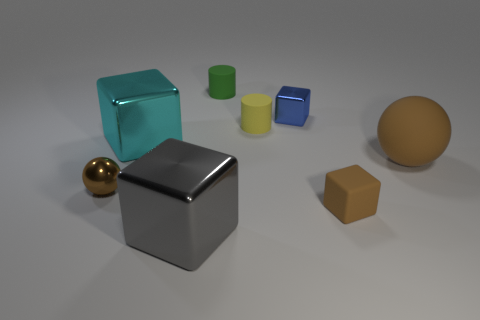What number of other objects are the same color as the small rubber block?
Offer a very short reply. 2. What number of yellow things are either small balls or large balls?
Your response must be concise. 0. Is the shape of the big object right of the small green cylinder the same as the tiny matte thing that is right of the yellow matte cylinder?
Make the answer very short. No. What number of other things are made of the same material as the cyan thing?
Keep it short and to the point. 3. There is a shiny thing in front of the brown thing left of the cyan metal block; is there a small brown block that is in front of it?
Offer a very short reply. No. Is the material of the small brown ball the same as the tiny blue cube?
Your answer should be very brief. Yes. Is there anything else that is the same shape as the small blue shiny object?
Provide a succinct answer. Yes. What material is the brown object left of the small shiny thing that is on the right side of the tiny metal sphere made of?
Provide a succinct answer. Metal. Is the number of purple matte cubes the same as the number of tiny blocks?
Make the answer very short. No. There is a brown sphere that is right of the small blue metallic block; how big is it?
Provide a succinct answer. Large. 